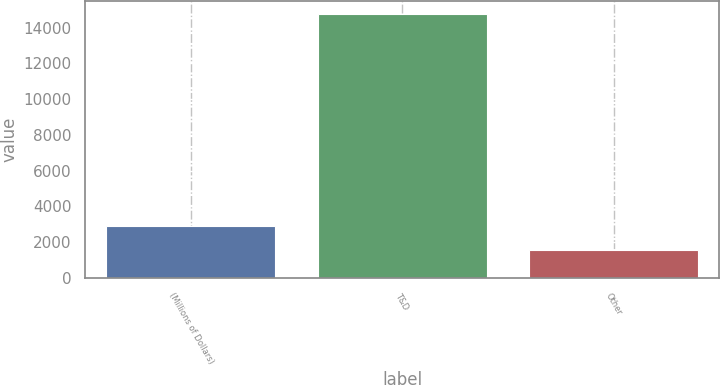<chart> <loc_0><loc_0><loc_500><loc_500><bar_chart><fcel>(Millions of Dollars)<fcel>T&D<fcel>Other<nl><fcel>2882.7<fcel>14742<fcel>1565<nl></chart> 